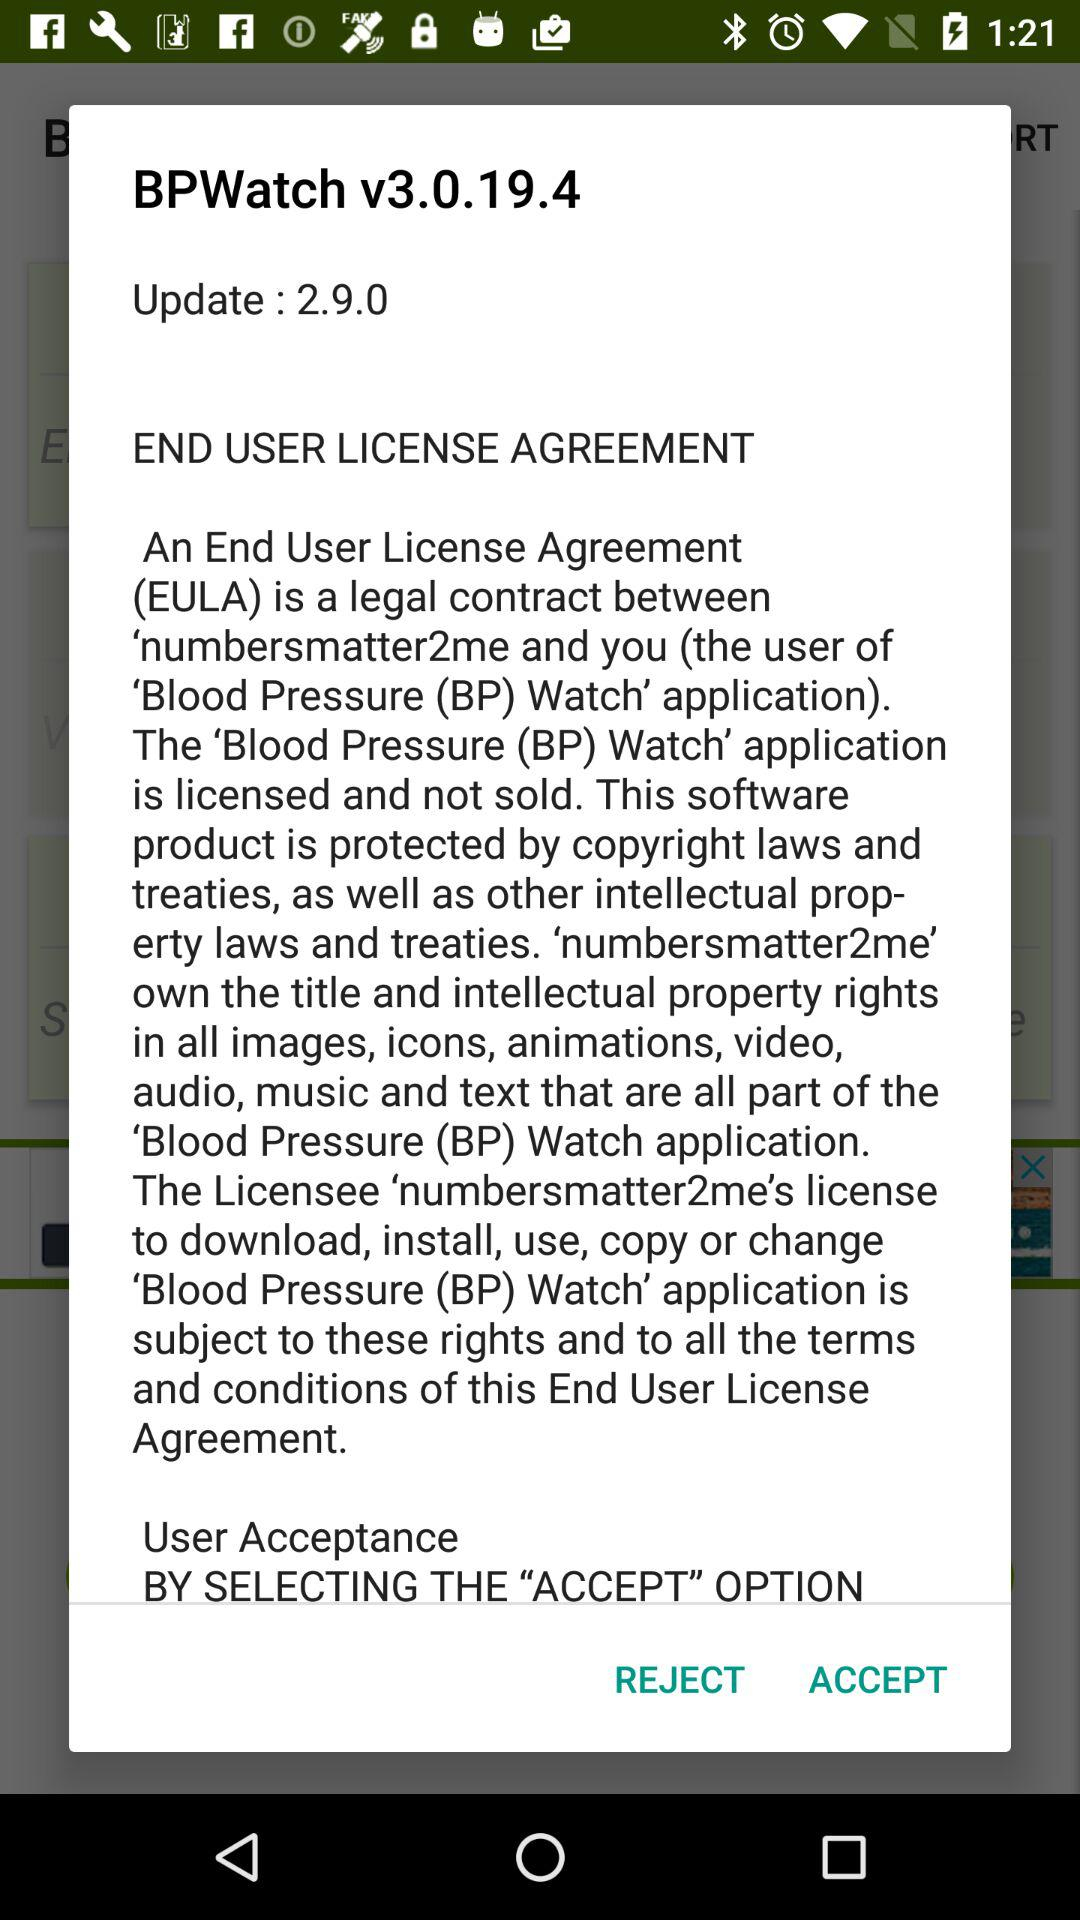What is the updated version? The updated version is 2.9.0. 